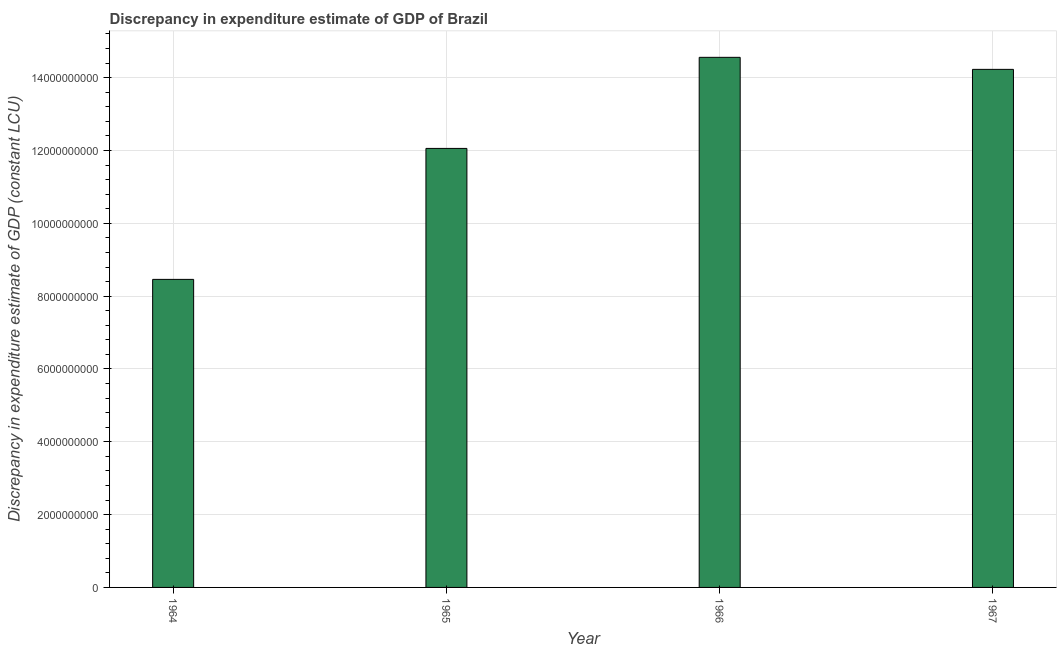What is the title of the graph?
Offer a very short reply. Discrepancy in expenditure estimate of GDP of Brazil. What is the label or title of the X-axis?
Your response must be concise. Year. What is the label or title of the Y-axis?
Give a very brief answer. Discrepancy in expenditure estimate of GDP (constant LCU). What is the discrepancy in expenditure estimate of gdp in 1966?
Your response must be concise. 1.46e+1. Across all years, what is the maximum discrepancy in expenditure estimate of gdp?
Your answer should be compact. 1.46e+1. Across all years, what is the minimum discrepancy in expenditure estimate of gdp?
Offer a very short reply. 8.46e+09. In which year was the discrepancy in expenditure estimate of gdp maximum?
Give a very brief answer. 1966. In which year was the discrepancy in expenditure estimate of gdp minimum?
Offer a very short reply. 1964. What is the sum of the discrepancy in expenditure estimate of gdp?
Your answer should be very brief. 4.93e+1. What is the difference between the discrepancy in expenditure estimate of gdp in 1965 and 1966?
Your response must be concise. -2.50e+09. What is the average discrepancy in expenditure estimate of gdp per year?
Give a very brief answer. 1.23e+1. What is the median discrepancy in expenditure estimate of gdp?
Offer a very short reply. 1.31e+1. In how many years, is the discrepancy in expenditure estimate of gdp greater than 7600000000 LCU?
Your answer should be compact. 4. What is the ratio of the discrepancy in expenditure estimate of gdp in 1965 to that in 1967?
Your answer should be compact. 0.85. Is the discrepancy in expenditure estimate of gdp in 1965 less than that in 1967?
Your answer should be very brief. Yes. What is the difference between the highest and the second highest discrepancy in expenditure estimate of gdp?
Keep it short and to the point. 3.31e+08. What is the difference between the highest and the lowest discrepancy in expenditure estimate of gdp?
Give a very brief answer. 6.10e+09. In how many years, is the discrepancy in expenditure estimate of gdp greater than the average discrepancy in expenditure estimate of gdp taken over all years?
Provide a succinct answer. 2. How many bars are there?
Offer a terse response. 4. Are all the bars in the graph horizontal?
Offer a very short reply. No. What is the Discrepancy in expenditure estimate of GDP (constant LCU) of 1964?
Your answer should be compact. 8.46e+09. What is the Discrepancy in expenditure estimate of GDP (constant LCU) of 1965?
Your response must be concise. 1.21e+1. What is the Discrepancy in expenditure estimate of GDP (constant LCU) in 1966?
Offer a very short reply. 1.46e+1. What is the Discrepancy in expenditure estimate of GDP (constant LCU) in 1967?
Your answer should be compact. 1.42e+1. What is the difference between the Discrepancy in expenditure estimate of GDP (constant LCU) in 1964 and 1965?
Your response must be concise. -3.60e+09. What is the difference between the Discrepancy in expenditure estimate of GDP (constant LCU) in 1964 and 1966?
Keep it short and to the point. -6.10e+09. What is the difference between the Discrepancy in expenditure estimate of GDP (constant LCU) in 1964 and 1967?
Make the answer very short. -5.77e+09. What is the difference between the Discrepancy in expenditure estimate of GDP (constant LCU) in 1965 and 1966?
Make the answer very short. -2.50e+09. What is the difference between the Discrepancy in expenditure estimate of GDP (constant LCU) in 1965 and 1967?
Keep it short and to the point. -2.17e+09. What is the difference between the Discrepancy in expenditure estimate of GDP (constant LCU) in 1966 and 1967?
Your response must be concise. 3.31e+08. What is the ratio of the Discrepancy in expenditure estimate of GDP (constant LCU) in 1964 to that in 1965?
Offer a very short reply. 0.7. What is the ratio of the Discrepancy in expenditure estimate of GDP (constant LCU) in 1964 to that in 1966?
Offer a very short reply. 0.58. What is the ratio of the Discrepancy in expenditure estimate of GDP (constant LCU) in 1964 to that in 1967?
Offer a terse response. 0.59. What is the ratio of the Discrepancy in expenditure estimate of GDP (constant LCU) in 1965 to that in 1966?
Keep it short and to the point. 0.83. What is the ratio of the Discrepancy in expenditure estimate of GDP (constant LCU) in 1965 to that in 1967?
Keep it short and to the point. 0.85. 